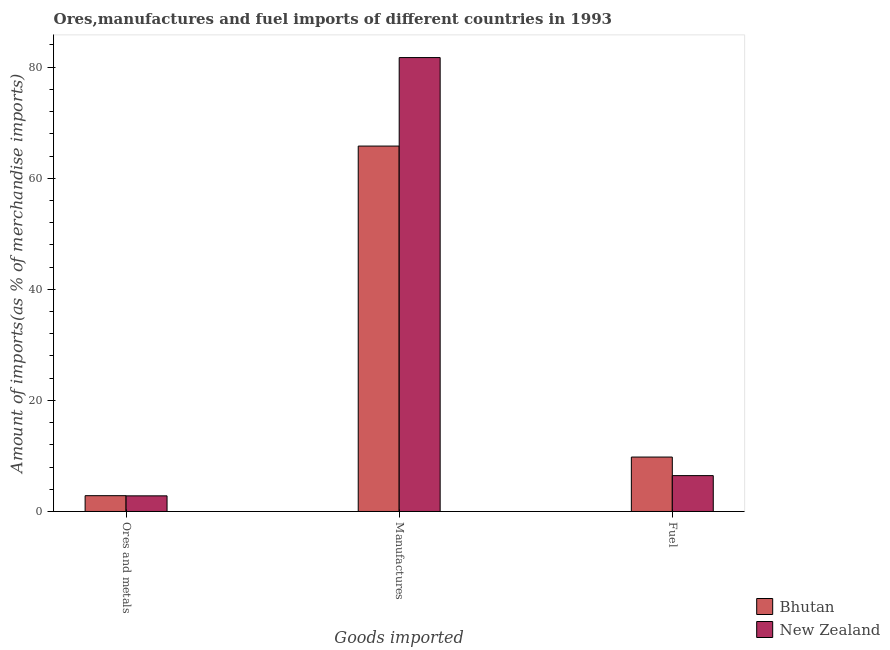What is the label of the 3rd group of bars from the left?
Your answer should be very brief. Fuel. What is the percentage of fuel imports in Bhutan?
Provide a succinct answer. 9.8. Across all countries, what is the maximum percentage of ores and metals imports?
Provide a succinct answer. 2.84. Across all countries, what is the minimum percentage of fuel imports?
Provide a succinct answer. 6.46. In which country was the percentage of manufactures imports maximum?
Provide a succinct answer. New Zealand. In which country was the percentage of ores and metals imports minimum?
Provide a succinct answer. New Zealand. What is the total percentage of ores and metals imports in the graph?
Your answer should be compact. 5.66. What is the difference between the percentage of manufactures imports in New Zealand and that in Bhutan?
Offer a terse response. 15.93. What is the difference between the percentage of fuel imports in Bhutan and the percentage of manufactures imports in New Zealand?
Ensure brevity in your answer.  -71.93. What is the average percentage of fuel imports per country?
Keep it short and to the point. 8.13. What is the difference between the percentage of ores and metals imports and percentage of fuel imports in Bhutan?
Offer a very short reply. -6.95. In how many countries, is the percentage of ores and metals imports greater than 76 %?
Provide a short and direct response. 0. What is the ratio of the percentage of ores and metals imports in New Zealand to that in Bhutan?
Ensure brevity in your answer.  0.99. Is the percentage of fuel imports in Bhutan less than that in New Zealand?
Your answer should be compact. No. What is the difference between the highest and the second highest percentage of fuel imports?
Offer a terse response. 3.34. What is the difference between the highest and the lowest percentage of ores and metals imports?
Give a very brief answer. 0.03. In how many countries, is the percentage of fuel imports greater than the average percentage of fuel imports taken over all countries?
Ensure brevity in your answer.  1. Is the sum of the percentage of manufactures imports in New Zealand and Bhutan greater than the maximum percentage of fuel imports across all countries?
Offer a very short reply. Yes. What does the 1st bar from the left in Manufactures represents?
Give a very brief answer. Bhutan. What does the 2nd bar from the right in Ores and metals represents?
Provide a short and direct response. Bhutan. How many bars are there?
Your answer should be very brief. 6. Are all the bars in the graph horizontal?
Ensure brevity in your answer.  No. Are the values on the major ticks of Y-axis written in scientific E-notation?
Keep it short and to the point. No. Does the graph contain any zero values?
Your response must be concise. No. Where does the legend appear in the graph?
Offer a very short reply. Bottom right. How many legend labels are there?
Make the answer very short. 2. How are the legend labels stacked?
Your answer should be compact. Vertical. What is the title of the graph?
Offer a very short reply. Ores,manufactures and fuel imports of different countries in 1993. Does "East Asia (developing only)" appear as one of the legend labels in the graph?
Give a very brief answer. No. What is the label or title of the X-axis?
Your answer should be very brief. Goods imported. What is the label or title of the Y-axis?
Offer a terse response. Amount of imports(as % of merchandise imports). What is the Amount of imports(as % of merchandise imports) in Bhutan in Ores and metals?
Keep it short and to the point. 2.84. What is the Amount of imports(as % of merchandise imports) in New Zealand in Ores and metals?
Offer a very short reply. 2.82. What is the Amount of imports(as % of merchandise imports) of Bhutan in Manufactures?
Your answer should be very brief. 65.79. What is the Amount of imports(as % of merchandise imports) in New Zealand in Manufactures?
Keep it short and to the point. 81.73. What is the Amount of imports(as % of merchandise imports) of Bhutan in Fuel?
Provide a short and direct response. 9.8. What is the Amount of imports(as % of merchandise imports) of New Zealand in Fuel?
Your answer should be compact. 6.46. Across all Goods imported, what is the maximum Amount of imports(as % of merchandise imports) in Bhutan?
Your response must be concise. 65.79. Across all Goods imported, what is the maximum Amount of imports(as % of merchandise imports) in New Zealand?
Give a very brief answer. 81.73. Across all Goods imported, what is the minimum Amount of imports(as % of merchandise imports) in Bhutan?
Make the answer very short. 2.84. Across all Goods imported, what is the minimum Amount of imports(as % of merchandise imports) in New Zealand?
Provide a short and direct response. 2.82. What is the total Amount of imports(as % of merchandise imports) in Bhutan in the graph?
Offer a very short reply. 78.44. What is the total Amount of imports(as % of merchandise imports) in New Zealand in the graph?
Your answer should be very brief. 91. What is the difference between the Amount of imports(as % of merchandise imports) in Bhutan in Ores and metals and that in Manufactures?
Provide a succinct answer. -62.95. What is the difference between the Amount of imports(as % of merchandise imports) of New Zealand in Ores and metals and that in Manufactures?
Provide a short and direct response. -78.91. What is the difference between the Amount of imports(as % of merchandise imports) in Bhutan in Ores and metals and that in Fuel?
Offer a very short reply. -6.95. What is the difference between the Amount of imports(as % of merchandise imports) in New Zealand in Ores and metals and that in Fuel?
Give a very brief answer. -3.64. What is the difference between the Amount of imports(as % of merchandise imports) in Bhutan in Manufactures and that in Fuel?
Your answer should be compact. 55.99. What is the difference between the Amount of imports(as % of merchandise imports) in New Zealand in Manufactures and that in Fuel?
Keep it short and to the point. 75.27. What is the difference between the Amount of imports(as % of merchandise imports) in Bhutan in Ores and metals and the Amount of imports(as % of merchandise imports) in New Zealand in Manufactures?
Offer a terse response. -78.88. What is the difference between the Amount of imports(as % of merchandise imports) of Bhutan in Ores and metals and the Amount of imports(as % of merchandise imports) of New Zealand in Fuel?
Ensure brevity in your answer.  -3.61. What is the difference between the Amount of imports(as % of merchandise imports) in Bhutan in Manufactures and the Amount of imports(as % of merchandise imports) in New Zealand in Fuel?
Ensure brevity in your answer.  59.33. What is the average Amount of imports(as % of merchandise imports) in Bhutan per Goods imported?
Keep it short and to the point. 26.15. What is the average Amount of imports(as % of merchandise imports) in New Zealand per Goods imported?
Keep it short and to the point. 30.33. What is the difference between the Amount of imports(as % of merchandise imports) of Bhutan and Amount of imports(as % of merchandise imports) of New Zealand in Ores and metals?
Offer a very short reply. 0.03. What is the difference between the Amount of imports(as % of merchandise imports) of Bhutan and Amount of imports(as % of merchandise imports) of New Zealand in Manufactures?
Keep it short and to the point. -15.93. What is the difference between the Amount of imports(as % of merchandise imports) of Bhutan and Amount of imports(as % of merchandise imports) of New Zealand in Fuel?
Your answer should be compact. 3.34. What is the ratio of the Amount of imports(as % of merchandise imports) in Bhutan in Ores and metals to that in Manufactures?
Keep it short and to the point. 0.04. What is the ratio of the Amount of imports(as % of merchandise imports) of New Zealand in Ores and metals to that in Manufactures?
Your response must be concise. 0.03. What is the ratio of the Amount of imports(as % of merchandise imports) in Bhutan in Ores and metals to that in Fuel?
Give a very brief answer. 0.29. What is the ratio of the Amount of imports(as % of merchandise imports) in New Zealand in Ores and metals to that in Fuel?
Ensure brevity in your answer.  0.44. What is the ratio of the Amount of imports(as % of merchandise imports) of Bhutan in Manufactures to that in Fuel?
Provide a short and direct response. 6.71. What is the ratio of the Amount of imports(as % of merchandise imports) in New Zealand in Manufactures to that in Fuel?
Provide a short and direct response. 12.65. What is the difference between the highest and the second highest Amount of imports(as % of merchandise imports) in Bhutan?
Offer a terse response. 55.99. What is the difference between the highest and the second highest Amount of imports(as % of merchandise imports) of New Zealand?
Your answer should be very brief. 75.27. What is the difference between the highest and the lowest Amount of imports(as % of merchandise imports) of Bhutan?
Ensure brevity in your answer.  62.95. What is the difference between the highest and the lowest Amount of imports(as % of merchandise imports) in New Zealand?
Your response must be concise. 78.91. 